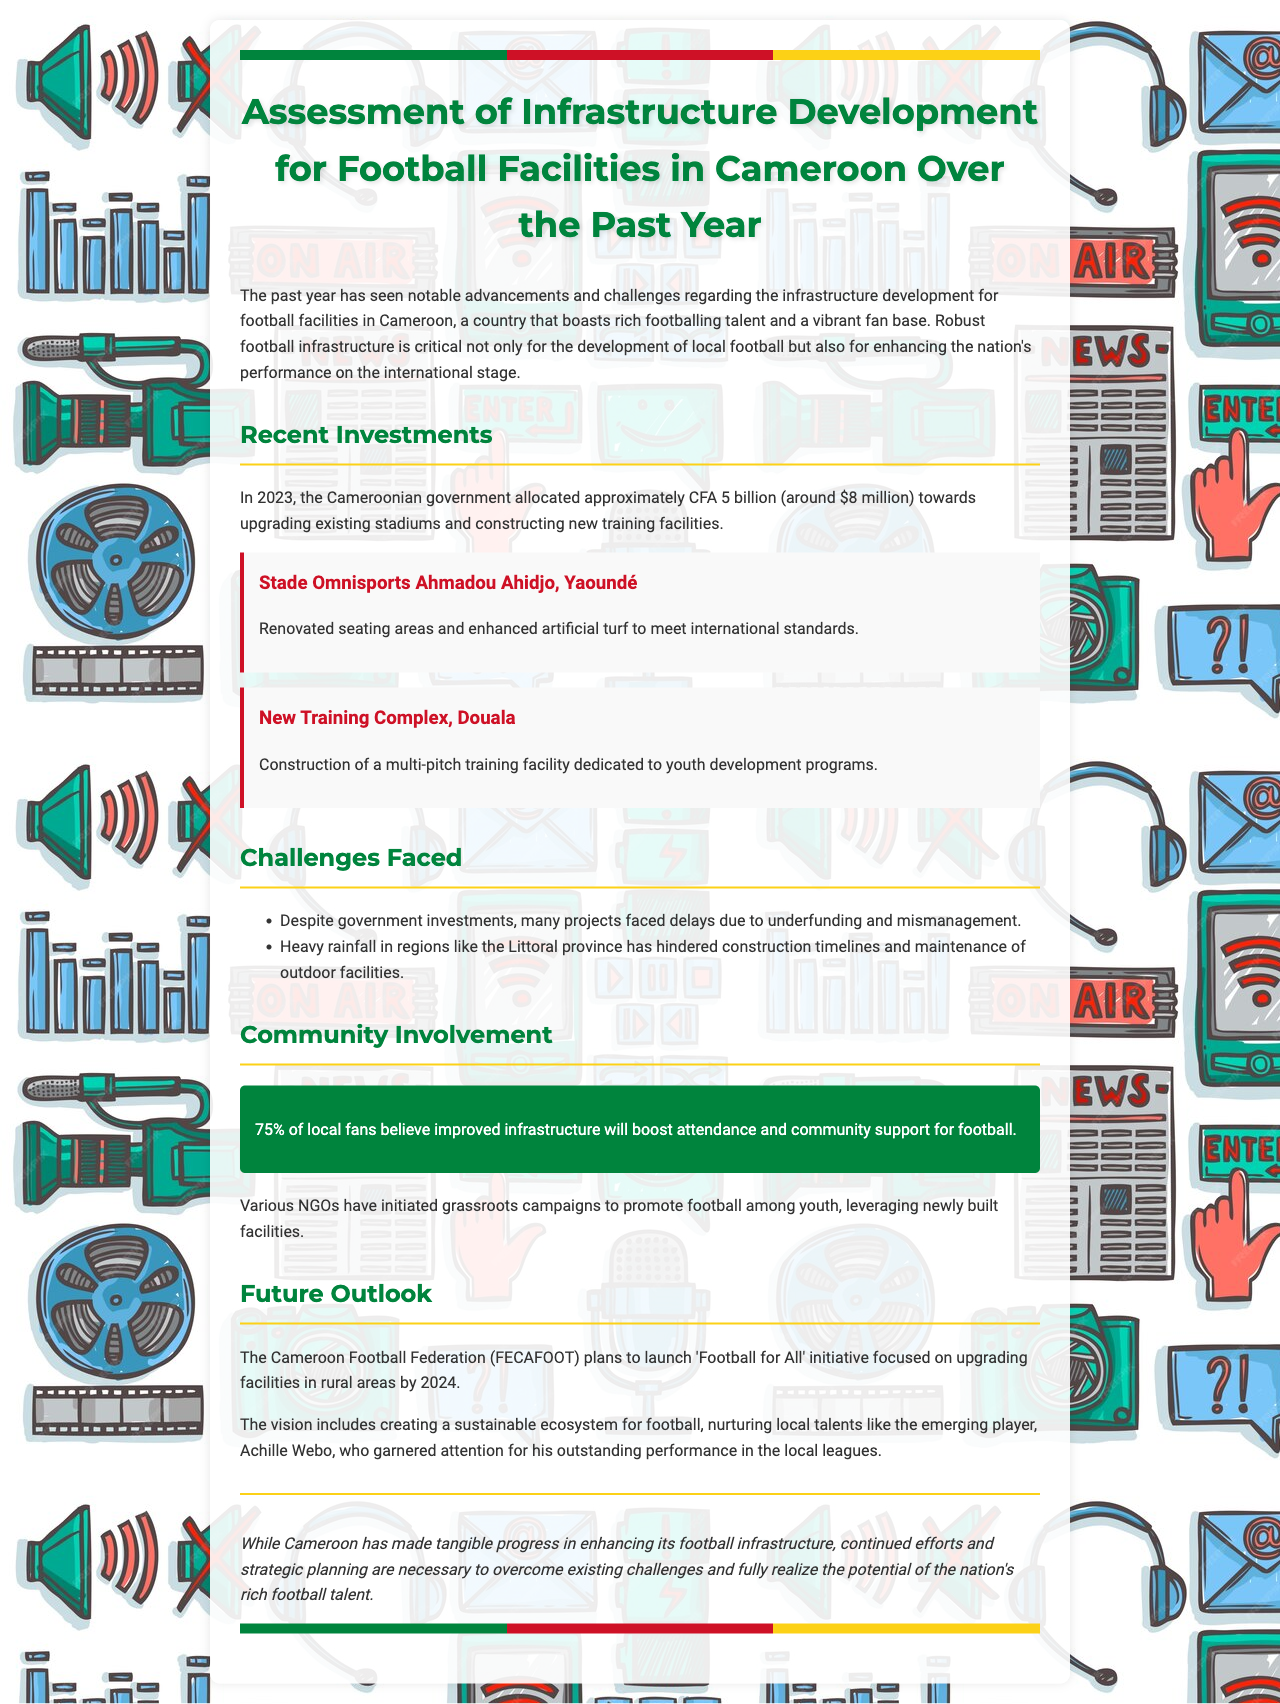What was the budget allocated by the government for 2023? The budget allocated by the government for 2023 is specified as approximately CFA 5 billion.
Answer: CFA 5 billion What new facility was constructed in Douala? The new facility mentioned in Douala is a multi-pitch training facility dedicated to youth development programs.
Answer: New Training Complex What percentage of local fans believe improved infrastructure will boost attendance? The document states that 75% of local fans believe improved infrastructure will boost attendance.
Answer: 75% What initiative does FECAFOOT plan to launch by 2024? The initiative planned by FECAFOOT is called 'Football for All.'
Answer: Football for All What challenge has hindered construction timelines in the Littoral province? The document highlights heavy rainfall as a challenge that has hindered construction timelines in the Littoral province.
Answer: Heavy rainfall 